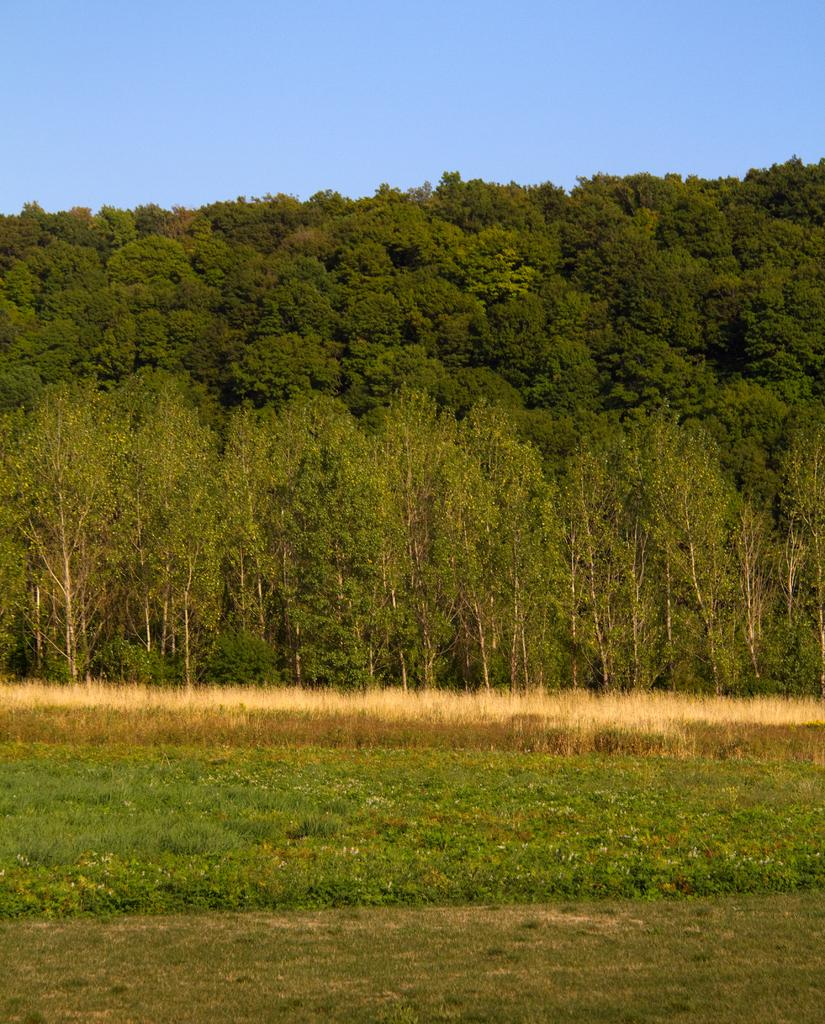What is the ground covered with in the image? The ground in the image is covered in greenery. What can be seen in front of the greenery? There are plants in front of the greenery. What is visible in the background of the image? There are trees in the background of the image. What level of the building can be seen in the image? There is no building present in the image; it features greenery, plants, and trees. What type of frame surrounds the image? The image does not have a frame; it is a digital representation of a scene. 